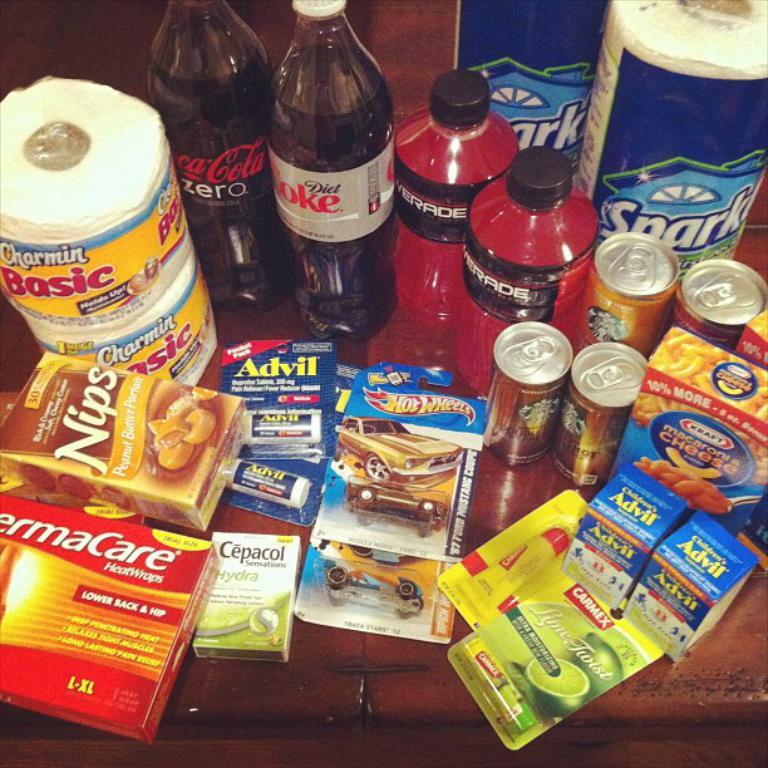<image>
Provide a brief description of the given image. Basic houseld supplies such as Charmin Basic, Coca Cola Zero, Coke Diet etc. 